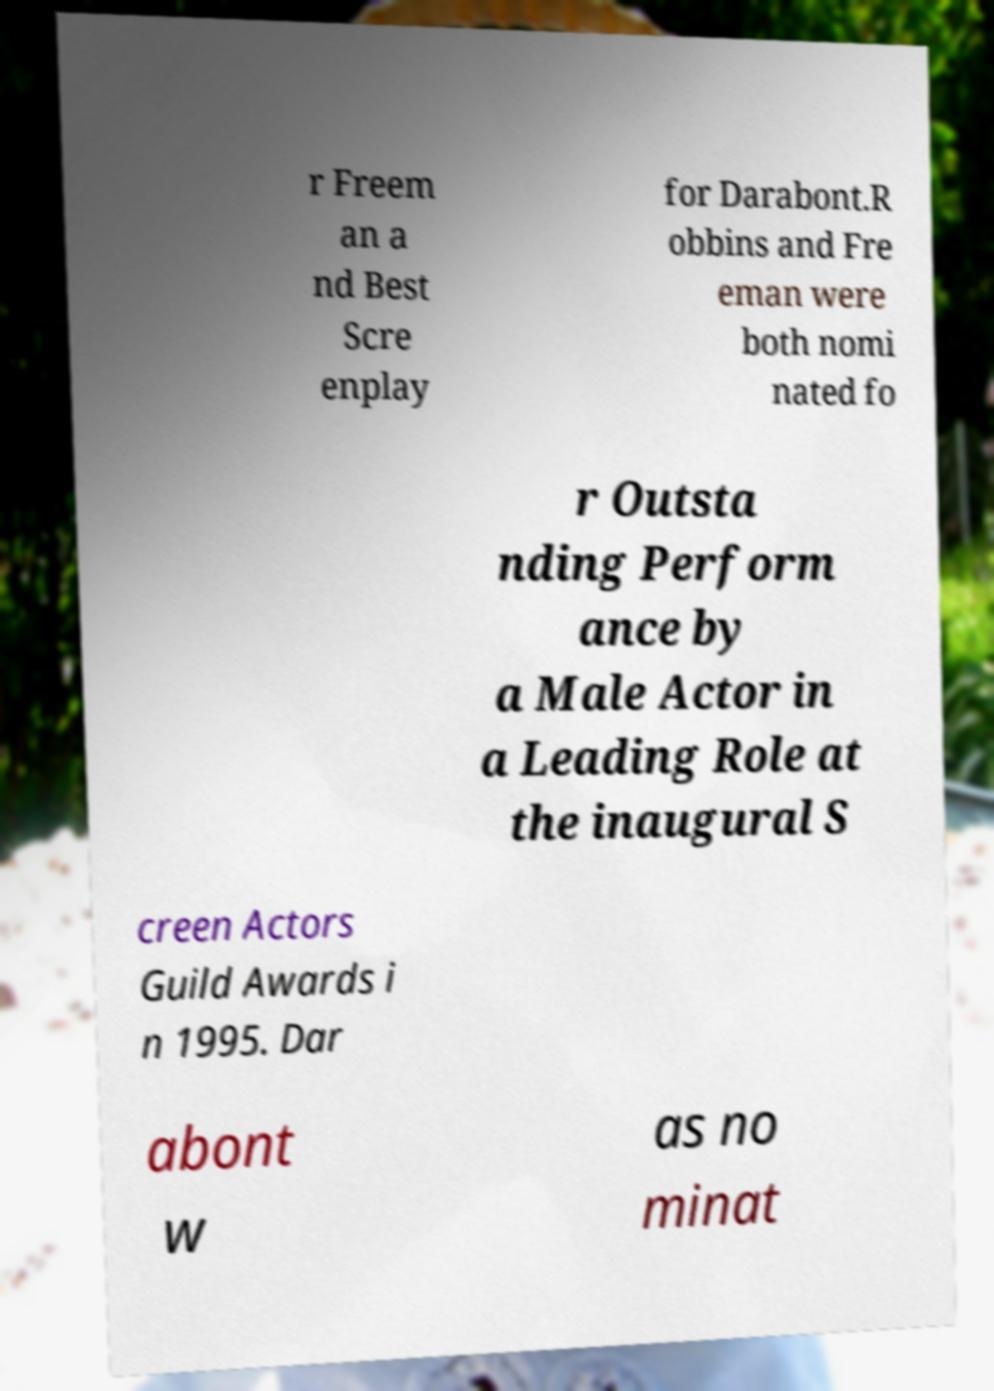Could you extract and type out the text from this image? r Freem an a nd Best Scre enplay for Darabont.R obbins and Fre eman were both nomi nated fo r Outsta nding Perform ance by a Male Actor in a Leading Role at the inaugural S creen Actors Guild Awards i n 1995. Dar abont w as no minat 